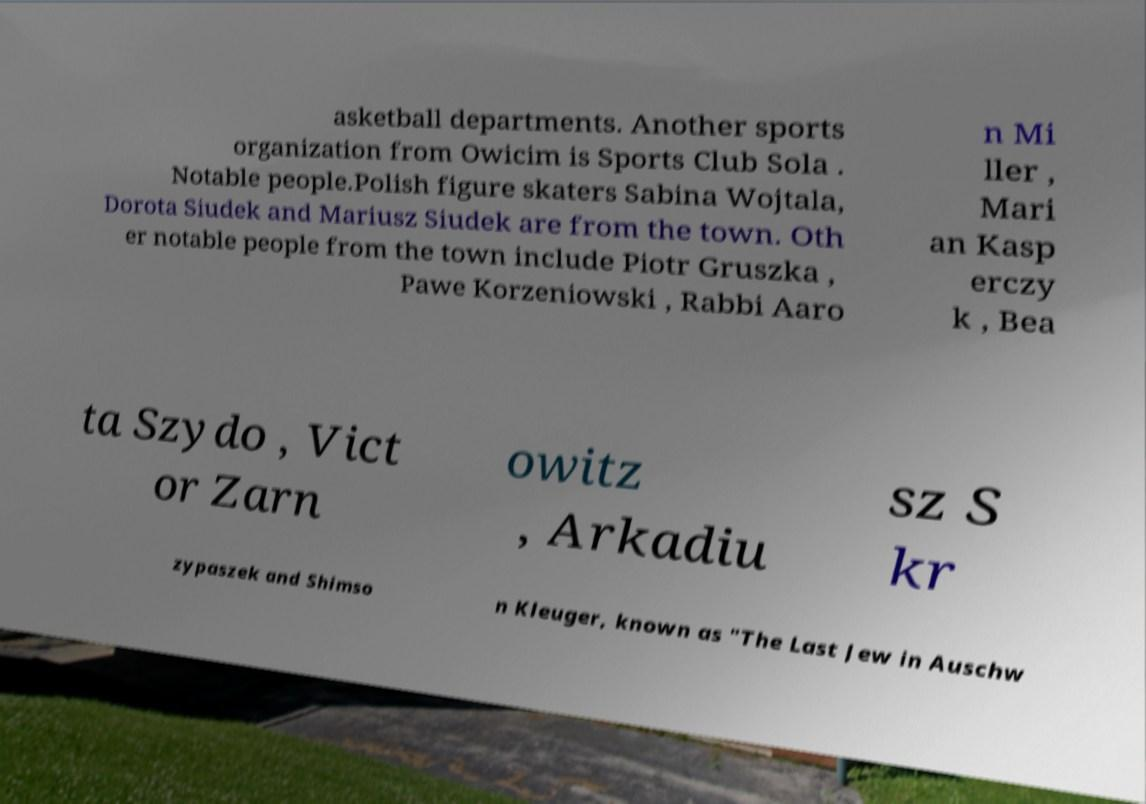Could you assist in decoding the text presented in this image and type it out clearly? asketball departments. Another sports organization from Owicim is Sports Club Sola . Notable people.Polish figure skaters Sabina Wojtala, Dorota Siudek and Mariusz Siudek are from the town. Oth er notable people from the town include Piotr Gruszka , Pawe Korzeniowski , Rabbi Aaro n Mi ller , Mari an Kasp erczy k , Bea ta Szydo , Vict or Zarn owitz , Arkadiu sz S kr zypaszek and Shimso n Kleuger, known as "The Last Jew in Auschw 